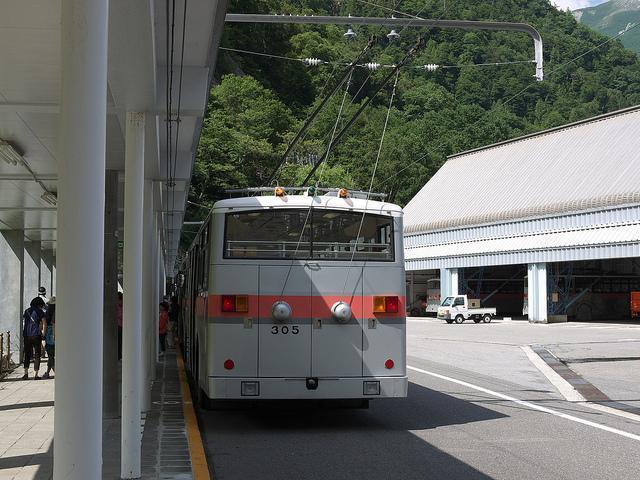Verify the accuracy of this image caption: "The truck is far away from the bus.".
Answer yes or no. Yes. 